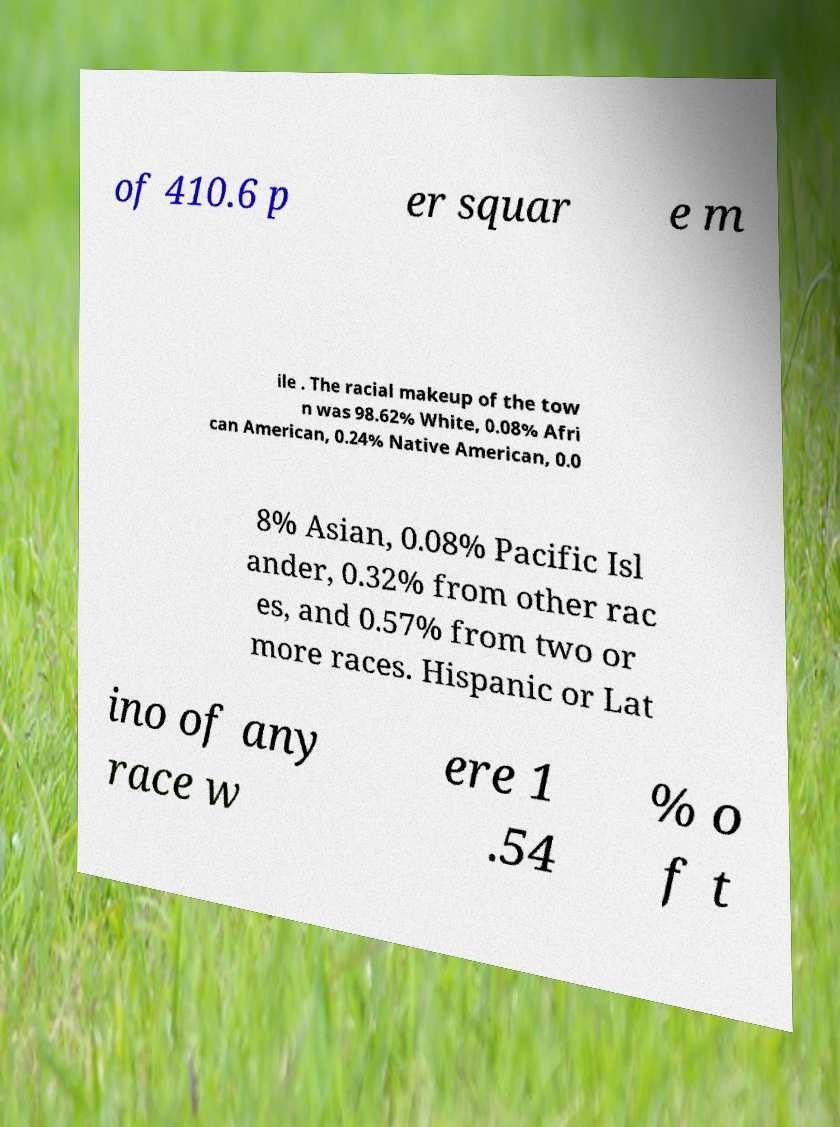For documentation purposes, I need the text within this image transcribed. Could you provide that? of 410.6 p er squar e m ile . The racial makeup of the tow n was 98.62% White, 0.08% Afri can American, 0.24% Native American, 0.0 8% Asian, 0.08% Pacific Isl ander, 0.32% from other rac es, and 0.57% from two or more races. Hispanic or Lat ino of any race w ere 1 .54 % o f t 